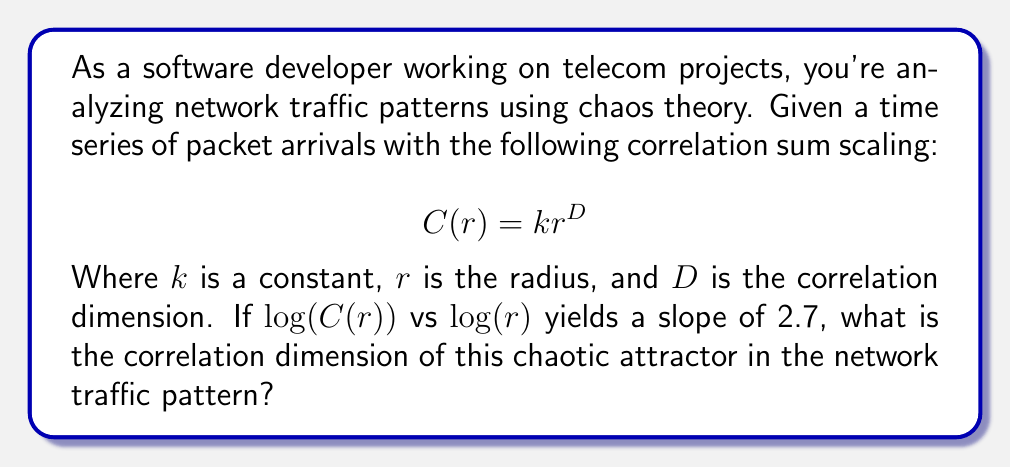Give your solution to this math problem. Let's approach this step-by-step:

1) The correlation sum $C(r)$ is given by the equation:

   $$C(r) = kr^D$$

2) Taking the logarithm of both sides:

   $$\log(C(r)) = \log(k) + D\log(r)$$

3) This is in the form of a linear equation $y = mx + b$, where:
   
   $y = \log(C(r))$
   $x = \log(r)$
   $m = D$ (the slope)
   $b = \log(k)$ (the y-intercept)

4) We're told that the slope of $\log(C(r))$ vs $\log(r)$ is 2.7.

5) In this linear equation, the slope $m$ is equal to the correlation dimension $D$.

Therefore, the correlation dimension $D$ is equal to the given slope, 2.7.
Answer: $D = 2.7$ 